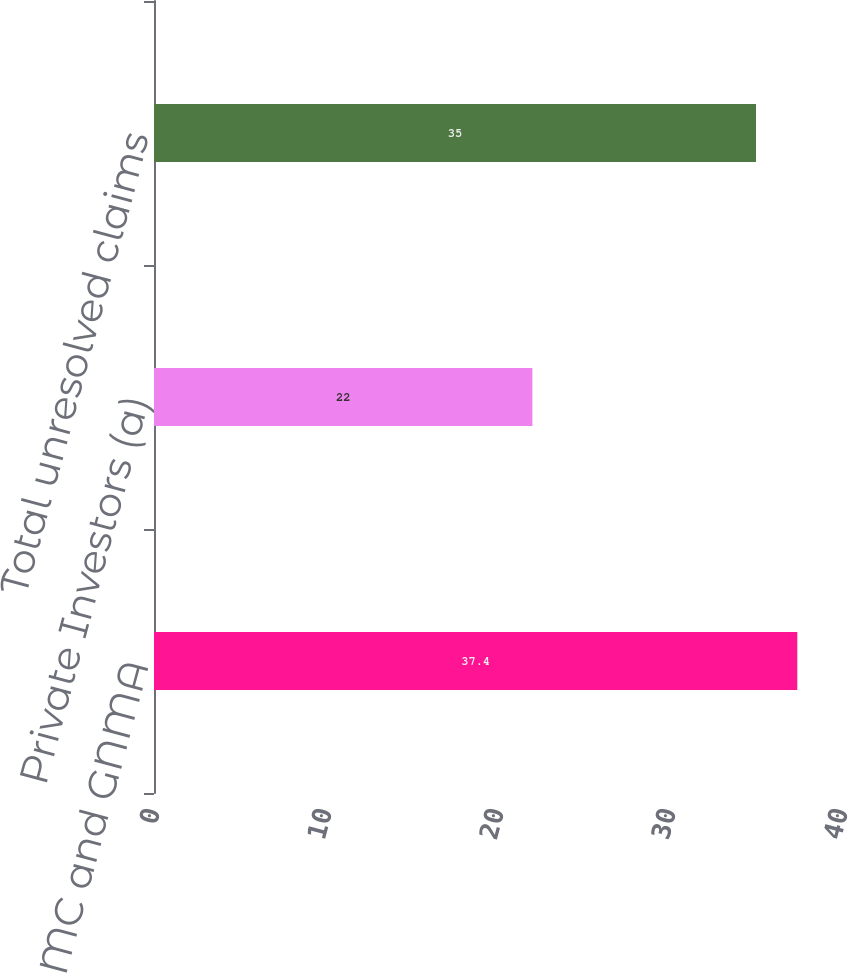<chart> <loc_0><loc_0><loc_500><loc_500><bar_chart><fcel>FNMA FHLMC and GNMA<fcel>Private Investors (a)<fcel>Total unresolved claims<nl><fcel>37.4<fcel>22<fcel>35<nl></chart> 